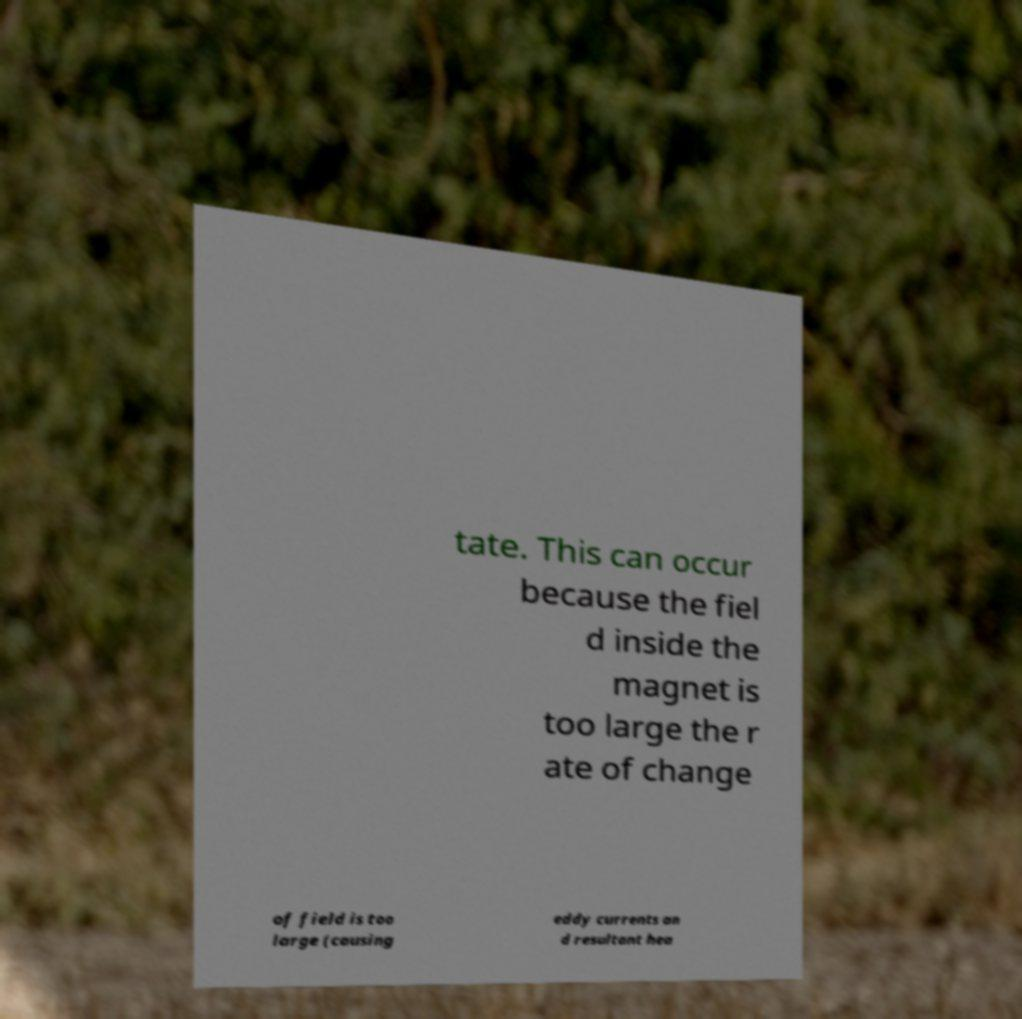Please read and relay the text visible in this image. What does it say? tate. This can occur because the fiel d inside the magnet is too large the r ate of change of field is too large (causing eddy currents an d resultant hea 